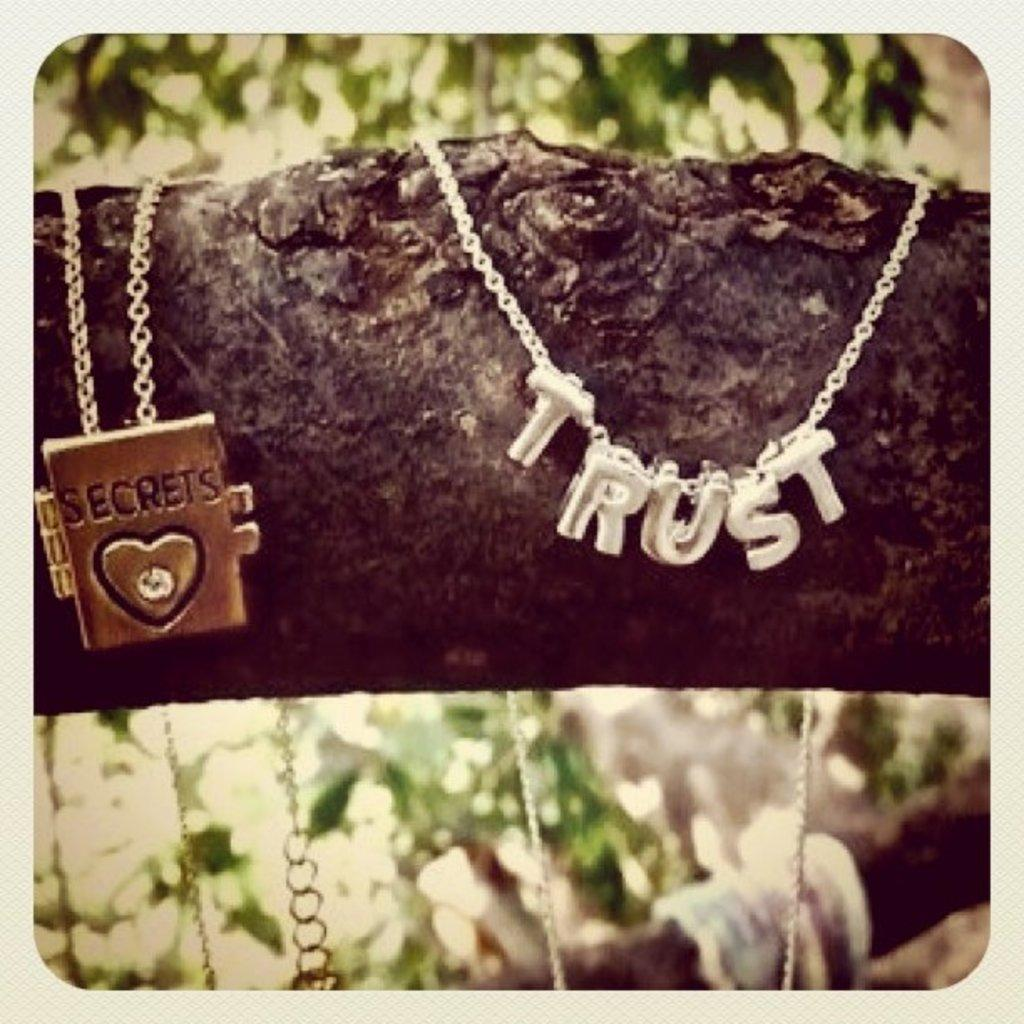Provide a one-sentence caption for the provided image. tree branch that has a two necklaces one has trust on it and the other has a book with word secrets on it. 